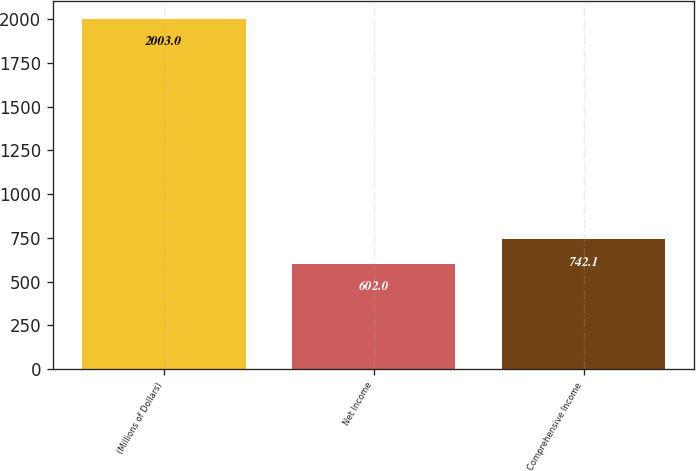<chart> <loc_0><loc_0><loc_500><loc_500><bar_chart><fcel>(Millions of Dollars)<fcel>Net Income<fcel>Comprehensive Income<nl><fcel>2003<fcel>602<fcel>742.1<nl></chart> 